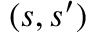<formula> <loc_0><loc_0><loc_500><loc_500>( s , s ^ { \prime } )</formula> 